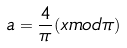Convert formula to latex. <formula><loc_0><loc_0><loc_500><loc_500>a = \frac { 4 } { \pi } ( x m o d \pi )</formula> 